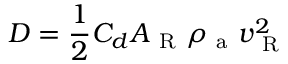<formula> <loc_0><loc_0><loc_500><loc_500>D = \frac { 1 } { 2 } C _ { d } A _ { R } \rho _ { a } v _ { R } ^ { 2 }</formula> 